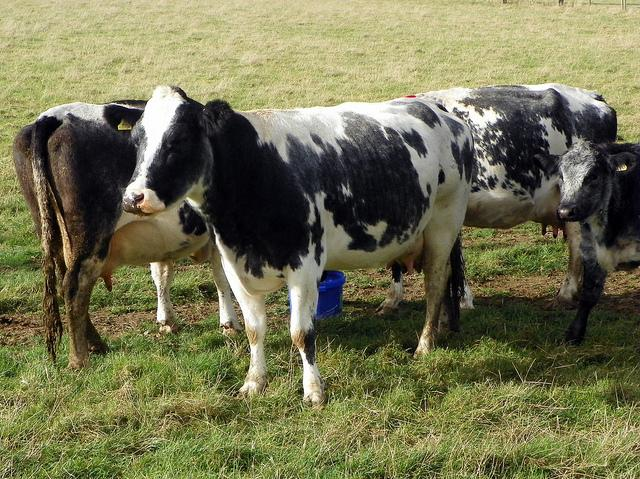Which animal look different than the cows in the picture?

Choices:
A) snake
B) chicken
C) goat
D) pig goat 